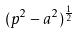<formula> <loc_0><loc_0><loc_500><loc_500>( p ^ { 2 } - a ^ { 2 } ) ^ { \frac { 1 } { 2 } }</formula> 